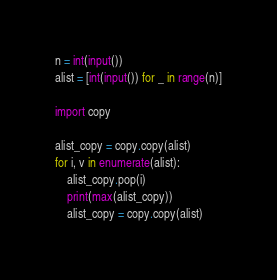Convert code to text. <code><loc_0><loc_0><loc_500><loc_500><_Python_>n = int(input())
alist = [int(input()) for _ in range(n)]

import copy

alist_copy = copy.copy(alist)
for i, v in enumerate(alist):
    alist_copy.pop(i)
    print(max(alist_copy))
    alist_copy = copy.copy(alist)</code> 